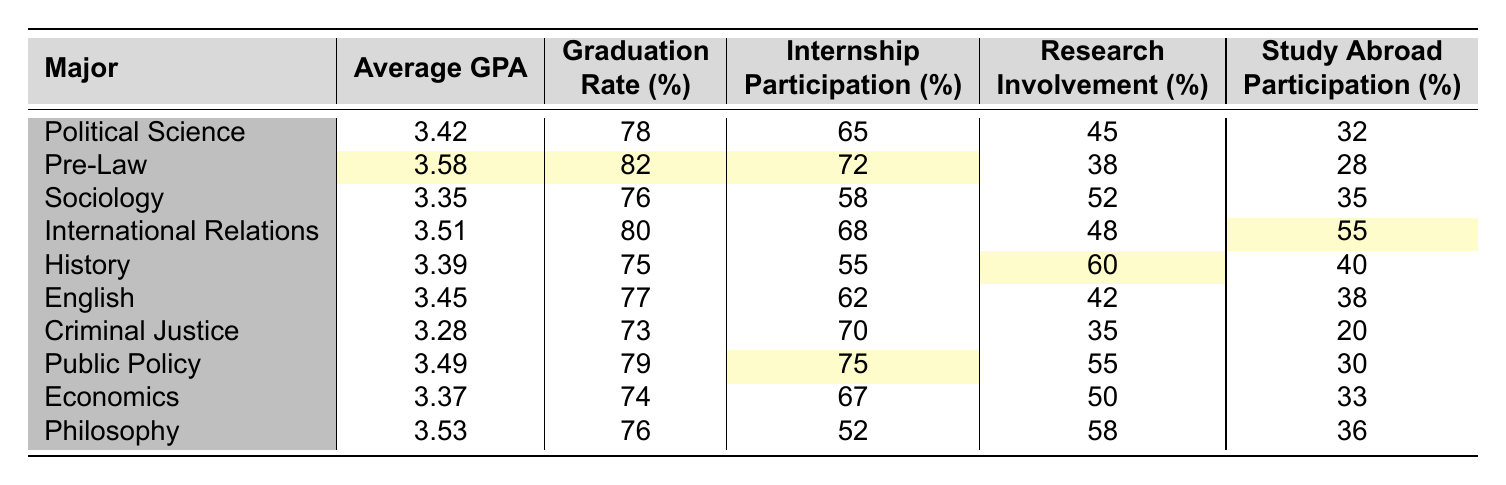What is the average GPA for students majoring in Pre-Law? The table shows that the average GPA for Pre-Law students is 3.58.
Answer: 3.58 Which major has the highest graduation rate? Looking at the graduation rates for all majors, Pre-Law has the highest rate at 82%.
Answer: 82% What is the internship participation rate for Sociology students? The table indicates that the internship participation rate for Sociology students is 58%.
Answer: 58% Is the average GPA for Criminal Justice higher than that of Sociology? The average GPA for Criminal Justice is 3.28, while for Sociology it is 3.35. Therefore, Criminal Justice has a lower average GPA.
Answer: No What is the difference in graduation rates between Public Policy and Political Science majors? The graduation rate for Public Policy is 79% and for Political Science it is 78%. The difference is 79% - 78% = 1%.
Answer: 1% If a student is majoring in International Relations, what is their combined rate of internship and research involvement? The internship participation rate is 68% and research involvement is 48%. Adding them gives 68% + 48% = 116%.
Answer: 116% Which major has the lowest study abroad participation rate? The table shows that Criminal Justice has the lowest study abroad participation rate at 20%.
Answer: 20% What majors have an average GPA higher than 3.50? The majors with an average GPA higher than 3.50 are Pre-Law (3.58), International Relations (3.51), and Philosophy (3.53).
Answer: Pre-Law, International Relations, Philosophy What is the average graduation rate for all majors listed in the table? The graduation rates are 78, 82, 76, 80, 75, 77, 73, 79, 74, and 76. Summing these rates gives 750, and dividing by 10 majors gives an average of 75%.
Answer: 75% Is there a major that has both the highest research involvement and high internship participation? International Relations has 48% research involvement and 68% internship participation, both of which are relatively high compared to other majors.
Answer: Yes 